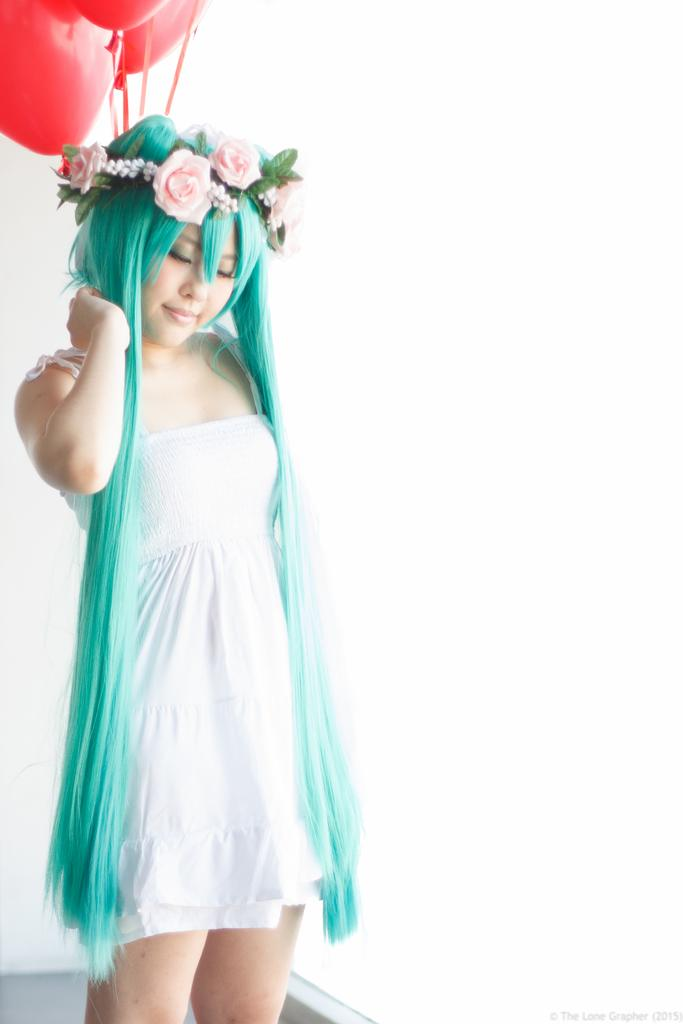Who is present in the image? There is a woman in the image. What is the woman doing in the image? The woman is standing and smiling. What can be seen in the image besides the woman? There are flowers and red balloons in the background of the image. What is the size of the yam in the image? There is no yam present in the image. How many people are in the group in the image? The image only features one woman, so there is no group present. 